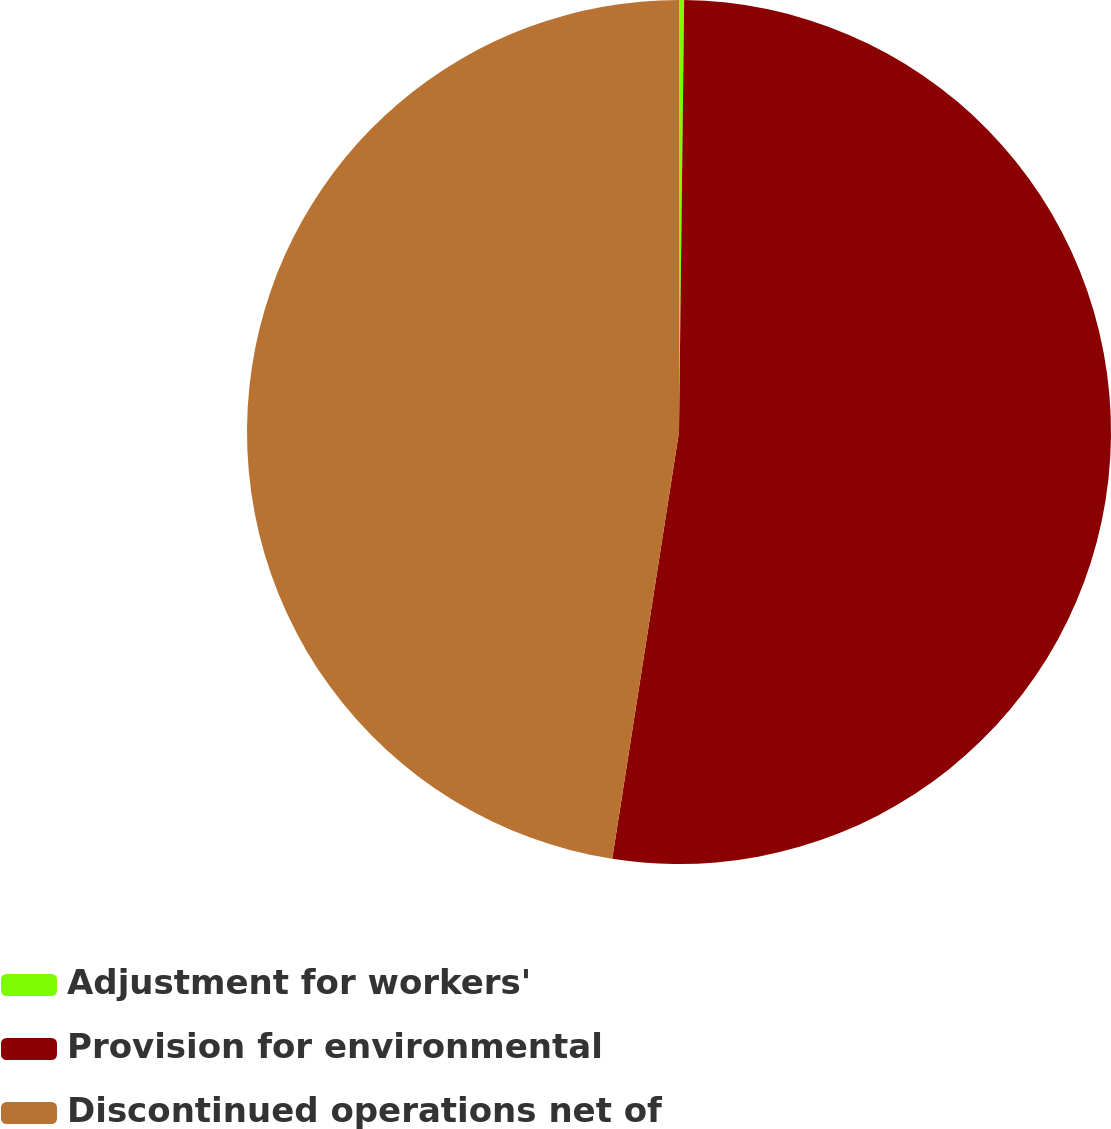Convert chart. <chart><loc_0><loc_0><loc_500><loc_500><pie_chart><fcel>Adjustment for workers'<fcel>Provision for environmental<fcel>Discontinued operations net of<nl><fcel>0.19%<fcel>52.28%<fcel>47.53%<nl></chart> 